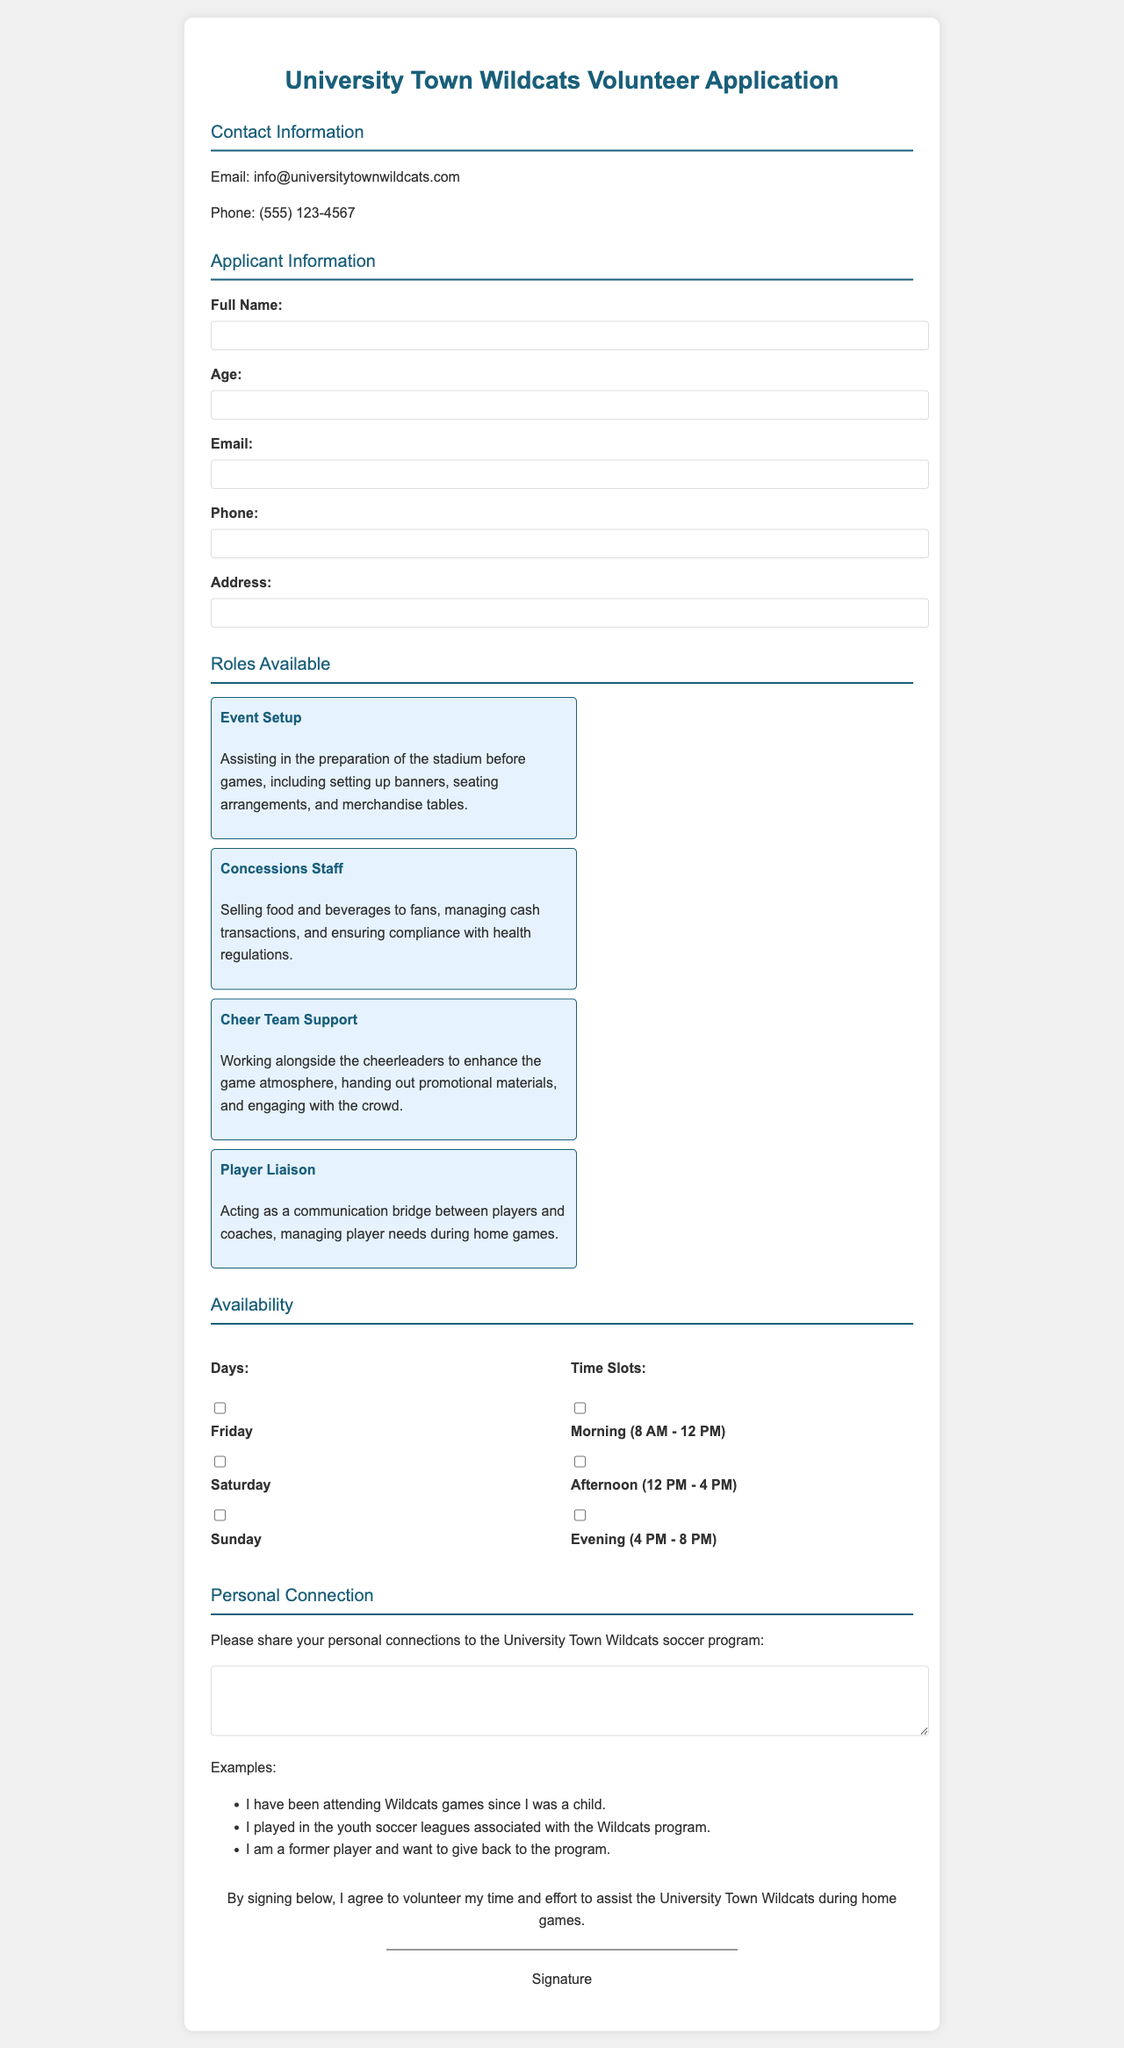what is the title of the form? The title of the form is prominently displayed at the top and provides the purpose of the document.
Answer: University Town Wildcats Volunteer Application what is the email contact provided? The email contact is listed under the contact information section for applicants to use.
Answer: info@universitytownwildcats.com how many roles are available for volunteers? The document lists the number of different roles available for assistance during home games.
Answer: 4 what is one example of a personal connection that can be shared? The document provides examples in a list for applicants to reference when sharing their connections.
Answer: I have been attending Wildcats games since I was a child what are the time slots available for volunteering? The volunteer application provides specific time frames during which applicants can express their availability to help.
Answer: Morning, Afternoon, Evening what role involves communication with players and coaches? The responsibilities of this role include managing player needs during home games.
Answer: Player Liaison which day of the week is mentioned as an option for volunteering? The document includes checkbox options for days of the week that applicants can select for availability.
Answer: Friday what is required information that must be filled out by the applicant? The document specifies key fields that users must complete to successfully submit the application.
Answer: Full Name, Age, Email, Phone, Address 